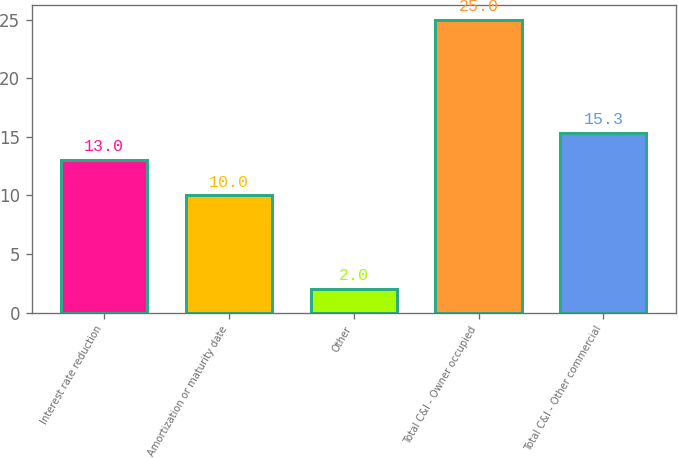<chart> <loc_0><loc_0><loc_500><loc_500><bar_chart><fcel>Interest rate reduction<fcel>Amortization or maturity date<fcel>Other<fcel>Total C&I - Owner occupied<fcel>Total C&I - Other commercial<nl><fcel>13<fcel>10<fcel>2<fcel>25<fcel>15.3<nl></chart> 